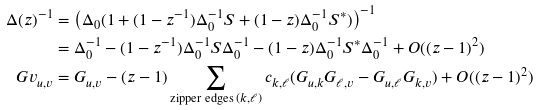<formula> <loc_0><loc_0><loc_500><loc_500>\Delta ( z ) ^ { - 1 } & = \left ( \Delta _ { 0 } ( 1 + ( 1 - z ^ { - 1 } ) \Delta _ { 0 } ^ { - 1 } S + ( 1 - z ) \Delta _ { 0 } ^ { - 1 } S ^ { * } ) \right ) ^ { - 1 } \\ & = \Delta _ { 0 } ^ { - 1 } - ( 1 - z ^ { - 1 } ) \Delta _ { 0 } ^ { - 1 } S \Delta _ { 0 } ^ { - 1 } - ( 1 - z ) \Delta _ { 0 } ^ { - 1 } S ^ { * } \Delta _ { 0 } ^ { - 1 } + O ( ( z - 1 ) ^ { 2 } ) \\ \ G v _ { u , v } & = G _ { u , v } - ( z - 1 ) \sum _ { \text {zipper edges } ( k , \ell ) } c _ { k , \ell } ( G _ { u , k } G _ { \ell , v } - G _ { u , \ell } G _ { k , v } ) + O ( ( z - 1 ) ^ { 2 } )</formula> 